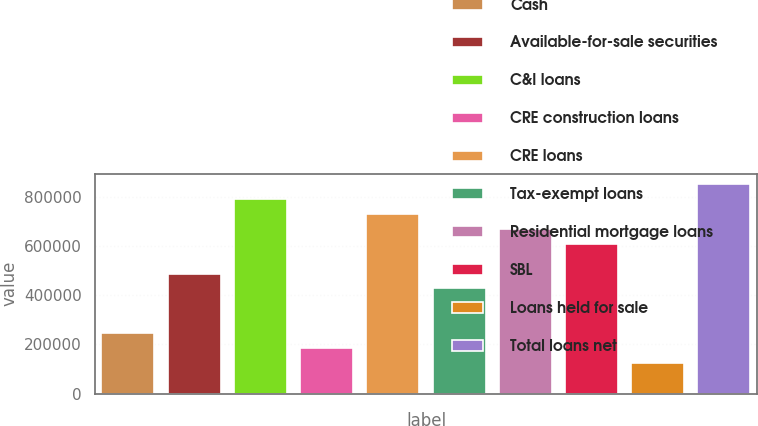<chart> <loc_0><loc_0><loc_500><loc_500><bar_chart><fcel>Cash<fcel>Available-for-sale securities<fcel>C&I loans<fcel>CRE construction loans<fcel>CRE loans<fcel>Tax-exempt loans<fcel>Residential mortgage loans<fcel>SBL<fcel>Loans held for sale<fcel>Total loans net<nl><fcel>246469<fcel>488804<fcel>791722<fcel>185885<fcel>731138<fcel>428220<fcel>670555<fcel>609971<fcel>125301<fcel>852306<nl></chart> 